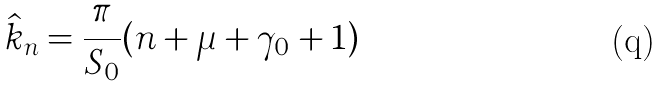Convert formula to latex. <formula><loc_0><loc_0><loc_500><loc_500>\hat { k } _ { n } = \frac { \pi } { S _ { 0 } } ( n + \mu + \gamma _ { 0 } + 1 )</formula> 